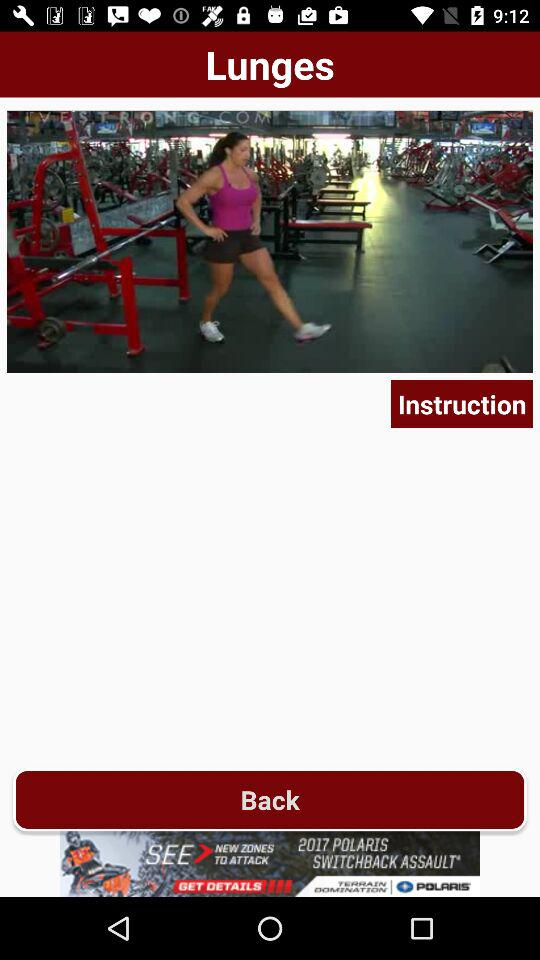How many lunge exercises are there?
When the provided information is insufficient, respond with <no answer>. <no answer> 